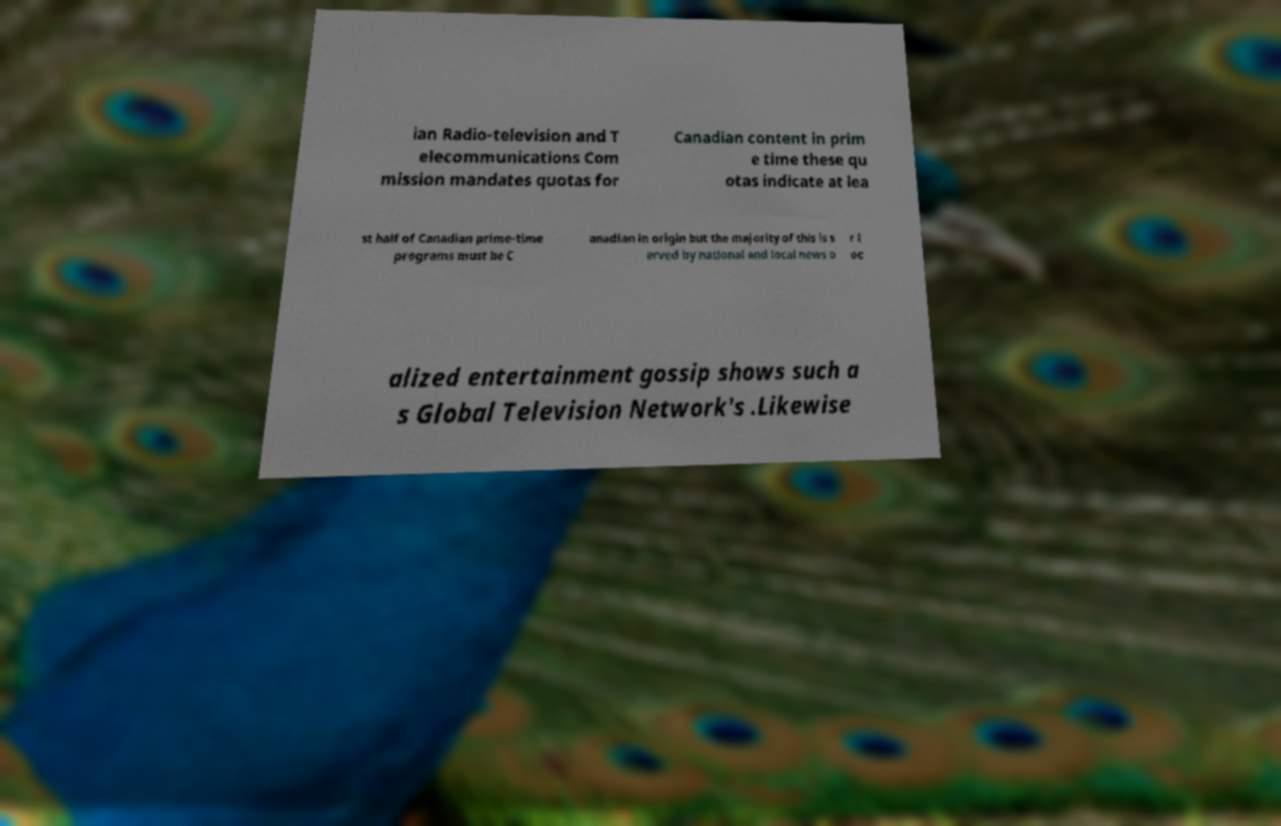Please identify and transcribe the text found in this image. ian Radio-television and T elecommunications Com mission mandates quotas for Canadian content in prim e time these qu otas indicate at lea st half of Canadian prime-time programs must be C anadian in origin but the majority of this is s erved by national and local news o r l oc alized entertainment gossip shows such a s Global Television Network's .Likewise 